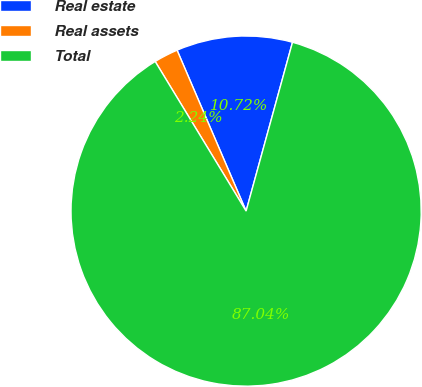Convert chart to OTSL. <chart><loc_0><loc_0><loc_500><loc_500><pie_chart><fcel>Real estate<fcel>Real assets<fcel>Total<nl><fcel>10.72%<fcel>2.24%<fcel>87.03%<nl></chart> 